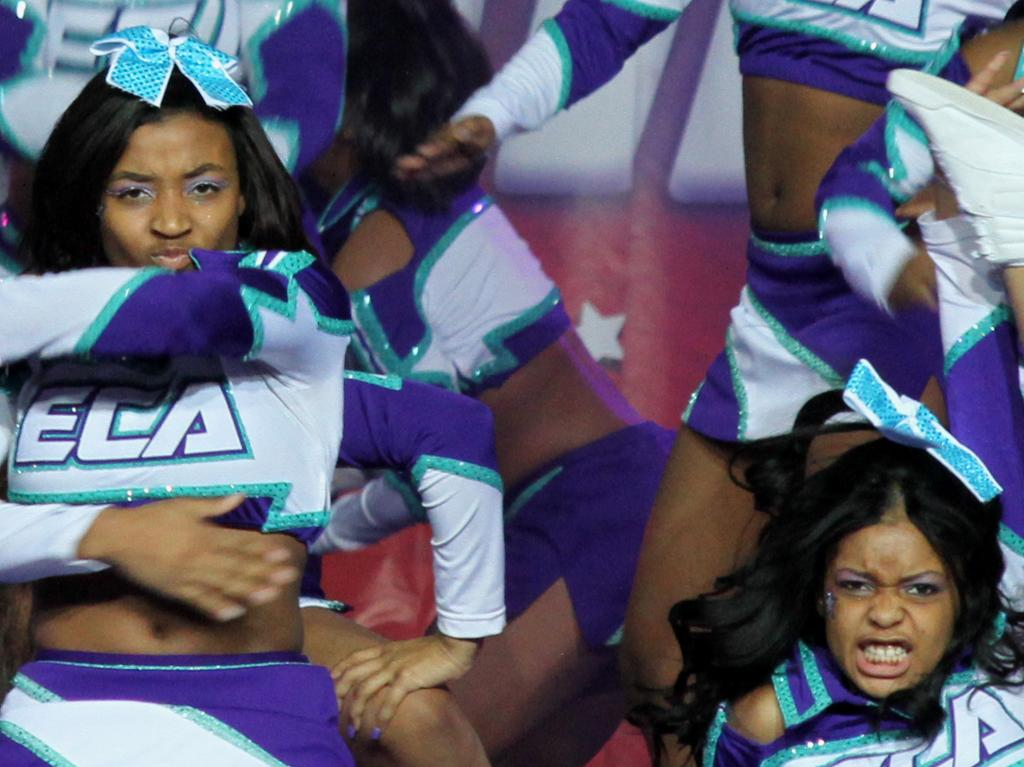<image>
Render a clear and concise summary of the photo. Many cheerleaders wear a uniform with ECA on the front. 